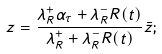Convert formula to latex. <formula><loc_0><loc_0><loc_500><loc_500>z = \frac { \lambda _ { R } ^ { + } \alpha _ { \tau } + \lambda _ { R } ^ { - } R ( t ) } { \lambda _ { R } ^ { + } + \lambda _ { R } ^ { - } R ( t ) } \bar { z } ;</formula> 